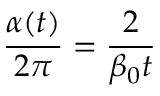Convert formula to latex. <formula><loc_0><loc_0><loc_500><loc_500>{ \frac { \alpha ( t ) } { 2 \pi } } = { \frac { 2 } { \beta _ { 0 } t } }</formula> 